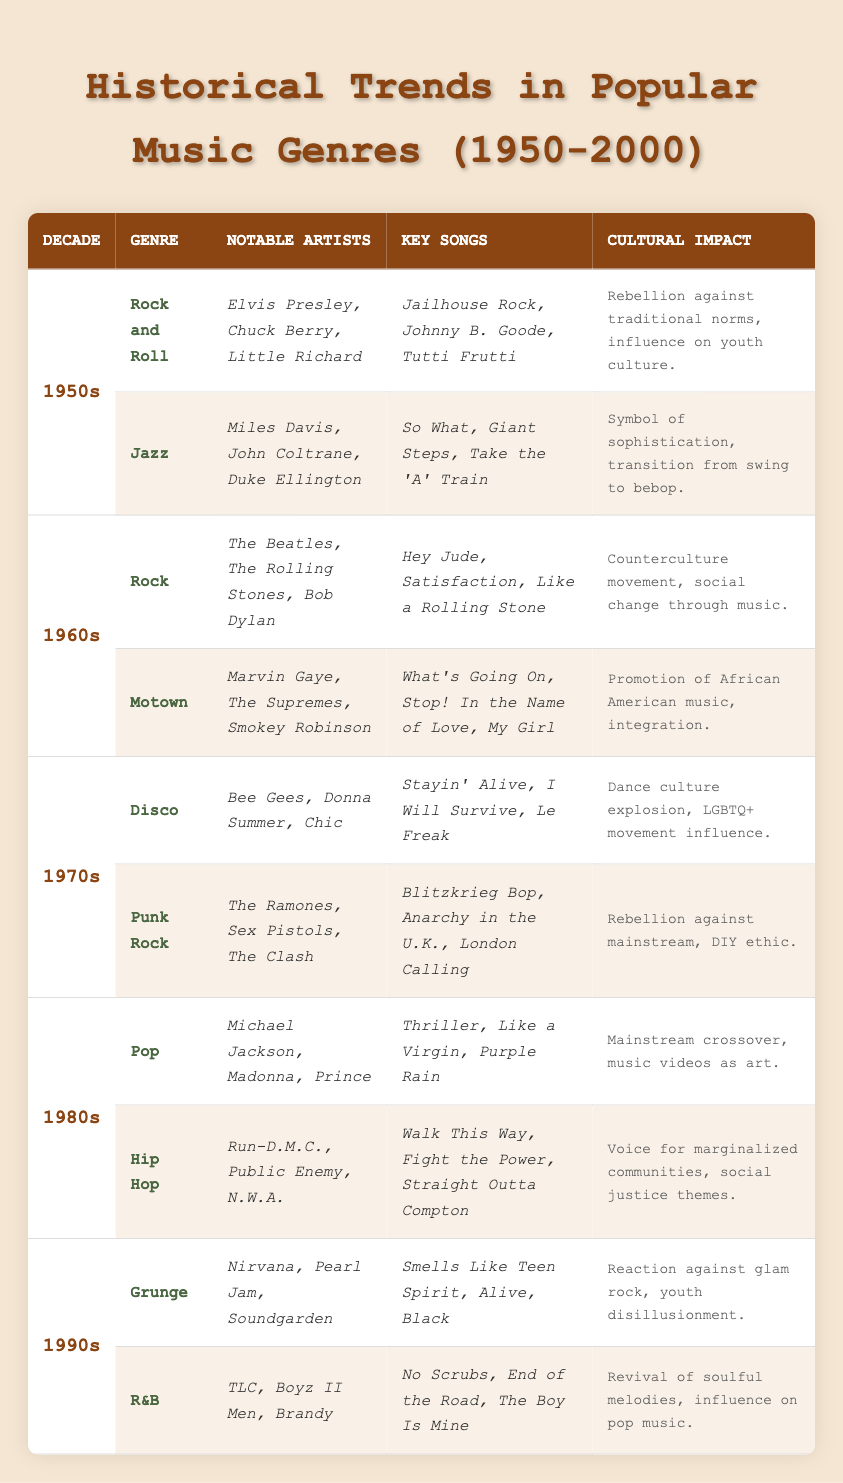What genre was prominent in the 1980s? Referring to the table, the primary genres listed for the 1980s are Pop and Hip Hop. Thus, both genres were prominent during this decade.
Answer: Pop and Hip Hop Who were notable artists in the 1970s Disco genre? Looking at the table, the notable artists for the Disco genre in the 1970s are Bee Gees, Donna Summer, and Chic.
Answer: Bee Gees, Donna Summer, Chic What song is associated with Nirvana in the 1990s? The table lists "Smells Like Teen Spirit," "Alive," and "Black" as key songs associated with Nirvana in the 1990s.
Answer: Smells Like Teen Spirit Which decade saw the rise of Punk Rock as a primary genre? According to the table, Punk Rock emerged as a primary genre in the 1970s.
Answer: 1970s Did Motown influence social integration? The cultural impact of Motown as noted in the table is the promotion of African American music and integration. Thus, it did influence social integration.
Answer: Yes How many primary genres are listed for the 1990s? The table indicates two primary genres for the 1990s: Grunge and R&B. Therefore, the total number of primary genres listed is two.
Answer: Two What are the key songs of the Jazz genre from the 1950s? From the table, the key songs of the Jazz genre from the 1950s are "So What," "Giant Steps," and "Take the 'A' Train."
Answer: So What, Giant Steps, Take the 'A' Train Which genre experienced a dance culture explosion in the 1970s? The table states that Disco music experienced a dance culture explosion in the 1970s, making it the genre associated with this impact.
Answer: Disco Who were the notable artists of the Rock genre in the 1960s? Referring to the table, the notable artists in the 1960s Rock genre include The Beatles, The Rolling Stones, and Bob Dylan.
Answer: The Beatles, The Rolling Stones, Bob Dylan Which genre's cultural impact involved a rebellion against traditional norms? The table indicates that Rock and Roll from the 1950s had a cultural impact of rebellion against traditional norms.
Answer: Rock and Roll How many key songs are associated with the R&B genre from the 1990s? The R&B genre from the 1990s includes three key songs as per the table: "No Scrubs," "End of the Road," and "The Boy Is Mine." Therefore, the total is three.
Answer: Three Which decade featured Michael Jackson as a notable artist? The table shows that Michael Jackson was a notable artist in the 1980s, specifically within the Pop genre.
Answer: 1980s What cultural impact is associated with the Hip Hop genre? The table mentions that Hip Hop’s cultural impact was as a voice for marginalized communities and included social justice themes.
Answer: Voice for marginalized communities, social justice themes Overall, which genre showed musical integration in the 1960s? The table highlights Motown in the 1960s as a genre that promoted integration and highlighted African American music.
Answer: Motown What was the trend of music in the decade of the 1950s? Analyzing the table, the main trends in the 1950s were Rock and Roll and Jazz, each having significant cultural impacts on youth and sophistication respectively.
Answer: Rock and Roll and Jazz 